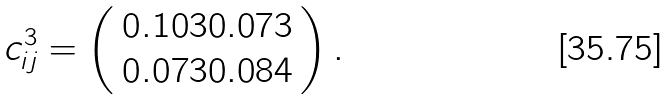<formula> <loc_0><loc_0><loc_500><loc_500>c _ { i j } ^ { 3 } = \left ( \begin{array} { c } 0 . 1 0 3 0 . 0 7 3 \\ 0 . 0 7 3 0 . 0 8 4 \end{array} \right ) .</formula> 